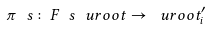Convert formula to latex. <formula><loc_0><loc_0><loc_500><loc_500>\pi \ s \colon F \ s \ u r o o t \rightarrow \ u r o o t _ { i } ^ { \prime }</formula> 